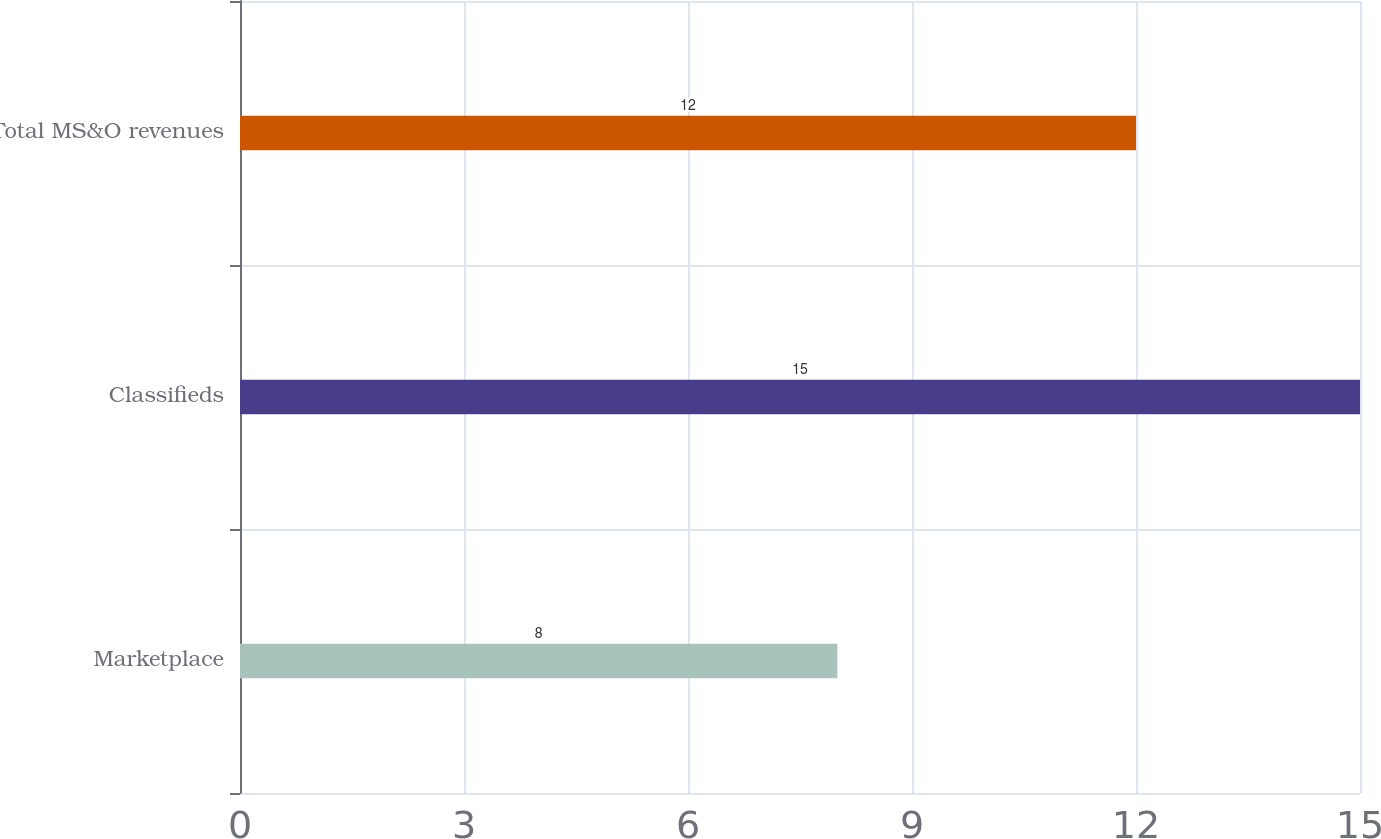Convert chart to OTSL. <chart><loc_0><loc_0><loc_500><loc_500><bar_chart><fcel>Marketplace<fcel>Classifieds<fcel>Total MS&O revenues<nl><fcel>8<fcel>15<fcel>12<nl></chart> 